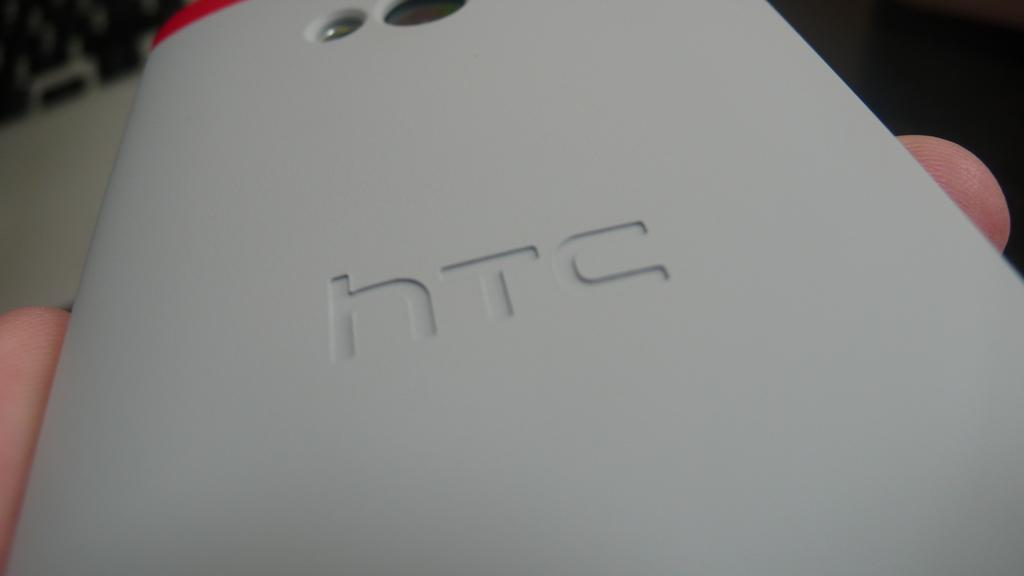Provide a one-sentence caption for the provided image. The back of an HTC phone with the camera lens and flash visible at the top. 